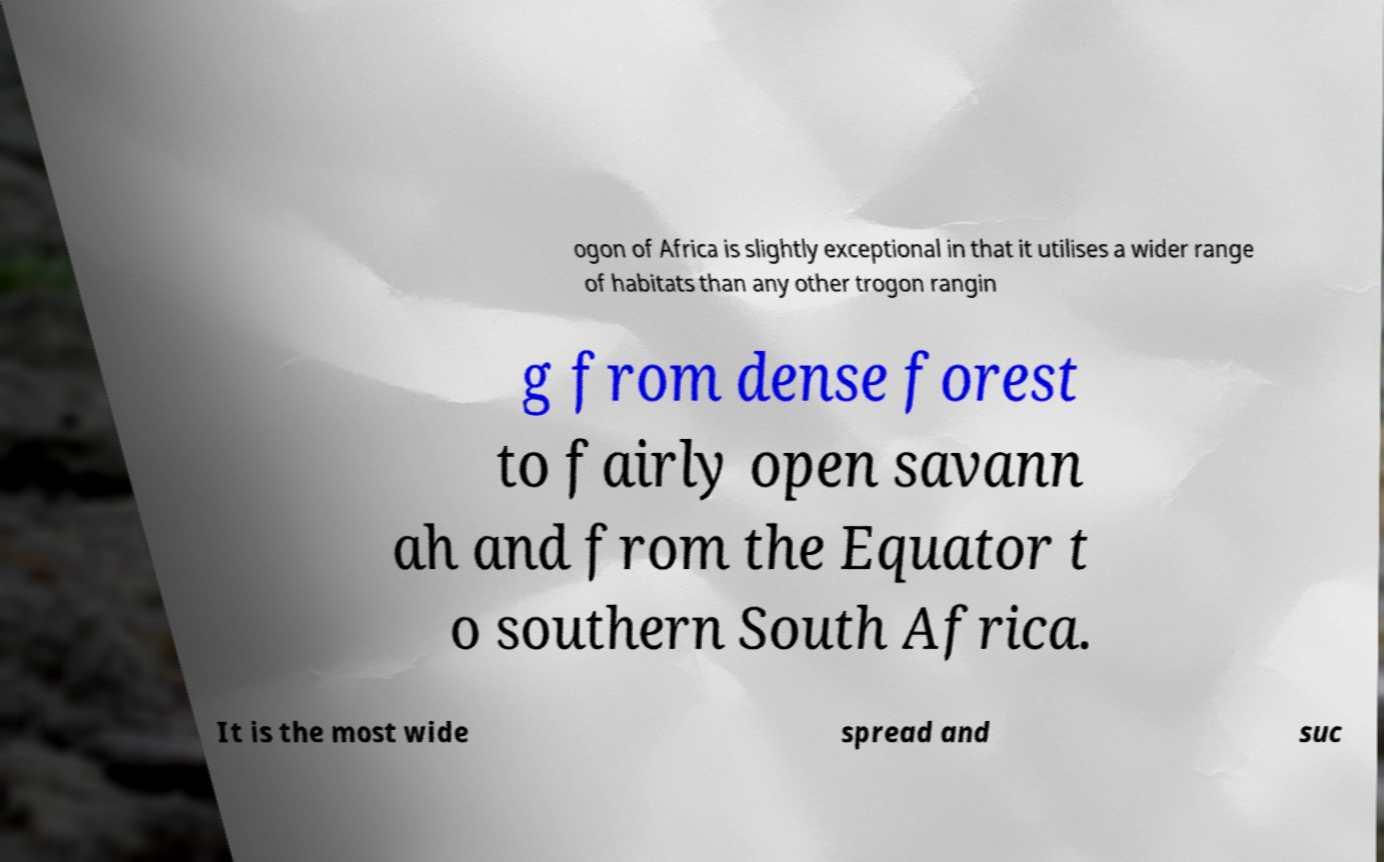There's text embedded in this image that I need extracted. Can you transcribe it verbatim? ogon of Africa is slightly exceptional in that it utilises a wider range of habitats than any other trogon rangin g from dense forest to fairly open savann ah and from the Equator t o southern South Africa. It is the most wide spread and suc 